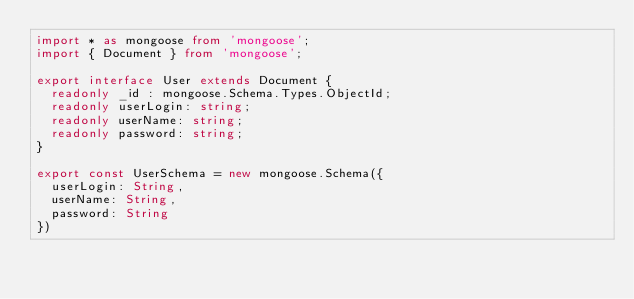Convert code to text. <code><loc_0><loc_0><loc_500><loc_500><_TypeScript_>import * as mongoose from 'mongoose';
import { Document } from 'mongoose';

export interface User extends Document {
  readonly _id : mongoose.Schema.Types.ObjectId;
  readonly userLogin: string;
  readonly userName: string;
  readonly password: string;
}

export const UserSchema = new mongoose.Schema({
  userLogin: String,
  userName: String,
  password: String
})
</code> 